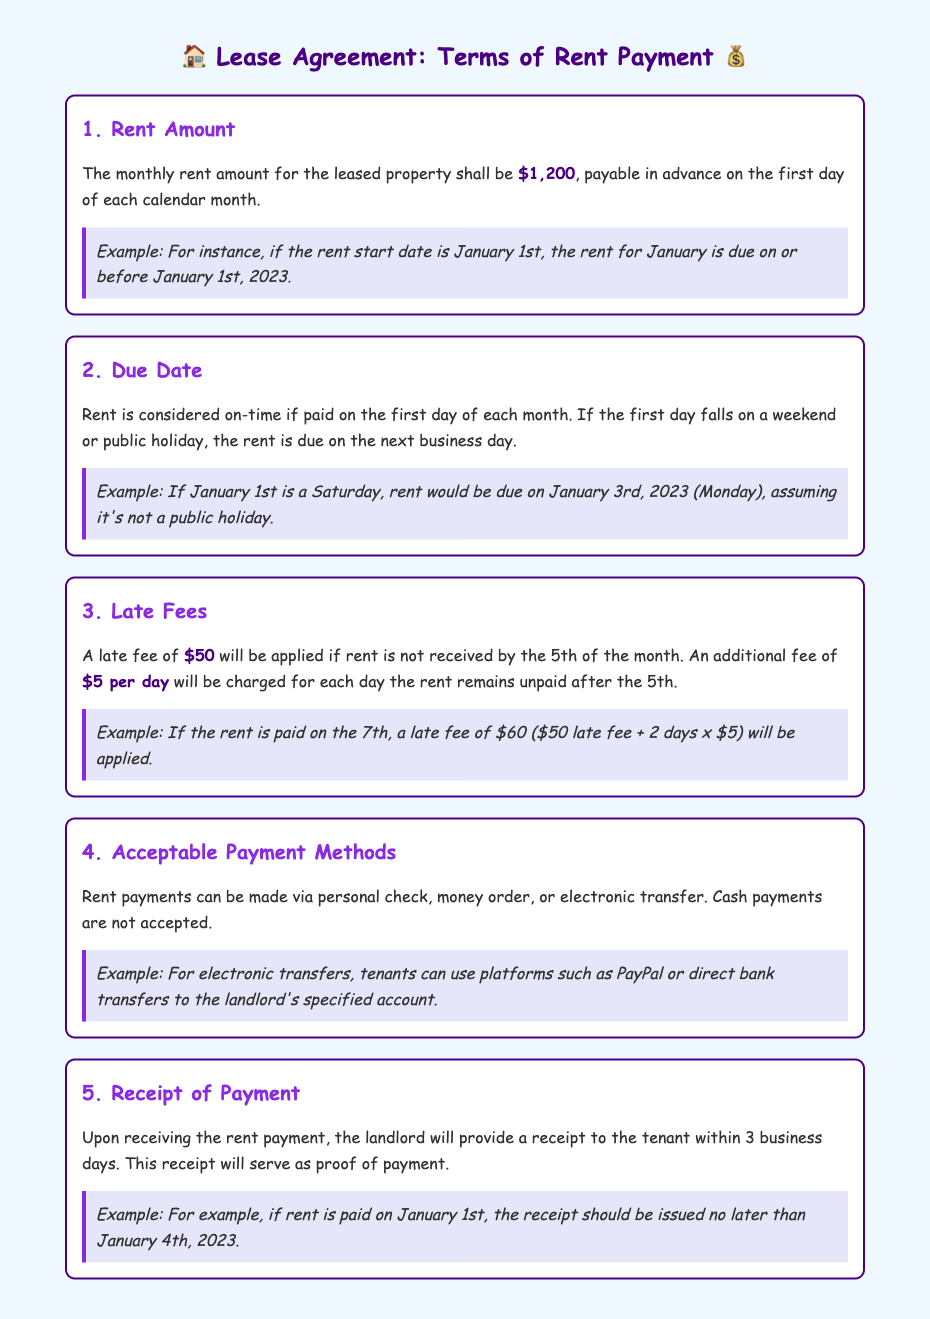What is the monthly rent amount? The document states that the monthly rent amount for the leased property is $1,200.
Answer: $1,200 When is the rent due? Rent is due on the first day of each calendar month, and if it falls on a weekend or holiday, the next business day.
Answer: First day of each month What is the late fee if rent is paid after the 5th? The late fee of $50 is applied if rent is not received by the 5th of the month.
Answer: $50 How much is the daily late fee after the 5th? An additional fee of $5 per day will be charged for each day the rent remains unpaid after the 5th.
Answer: $5 per day What payment methods are acceptable? Rent payments can be made via personal check, money order, or electronic transfer.
Answer: Personal check, money order, electronic transfer How long does the landlord have to provide a receipt? The landlord will provide a receipt to the tenant within 3 business days after receiving the rent payment.
Answer: 3 business days What happens if the rent is due on a holiday? If the rent due date falls on a holiday, it is due on the next business day.
Answer: Next business day What is the total late fee if paid on the 7th? The total late fee would be $60 if the rent is paid on the 7th of the month.
Answer: $60 